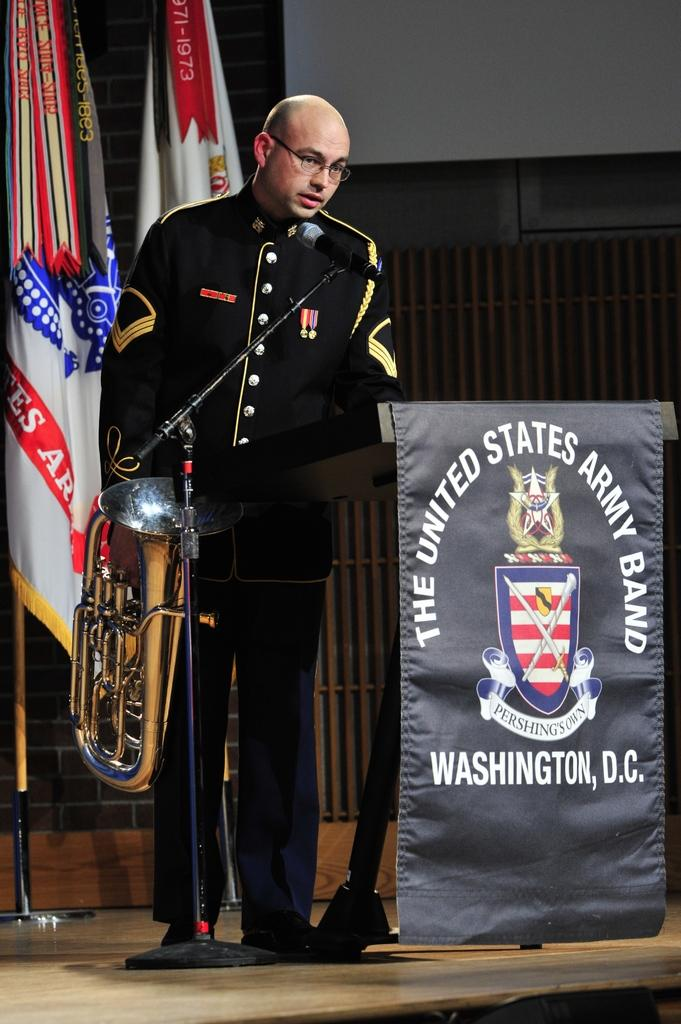What is the man in the image holding? The man is holding a musical instrument. What might the man be using to amplify his voice in the image? There is a microphone in front of the man. What can be seen in the background behind the man? There are flags and a hoarding visible behind the man. How much debt does the man owe in the image? There is no information about the man's debt in the image. What type of change can be seen on the floor in the image? There is no change visible on the floor in the image. 